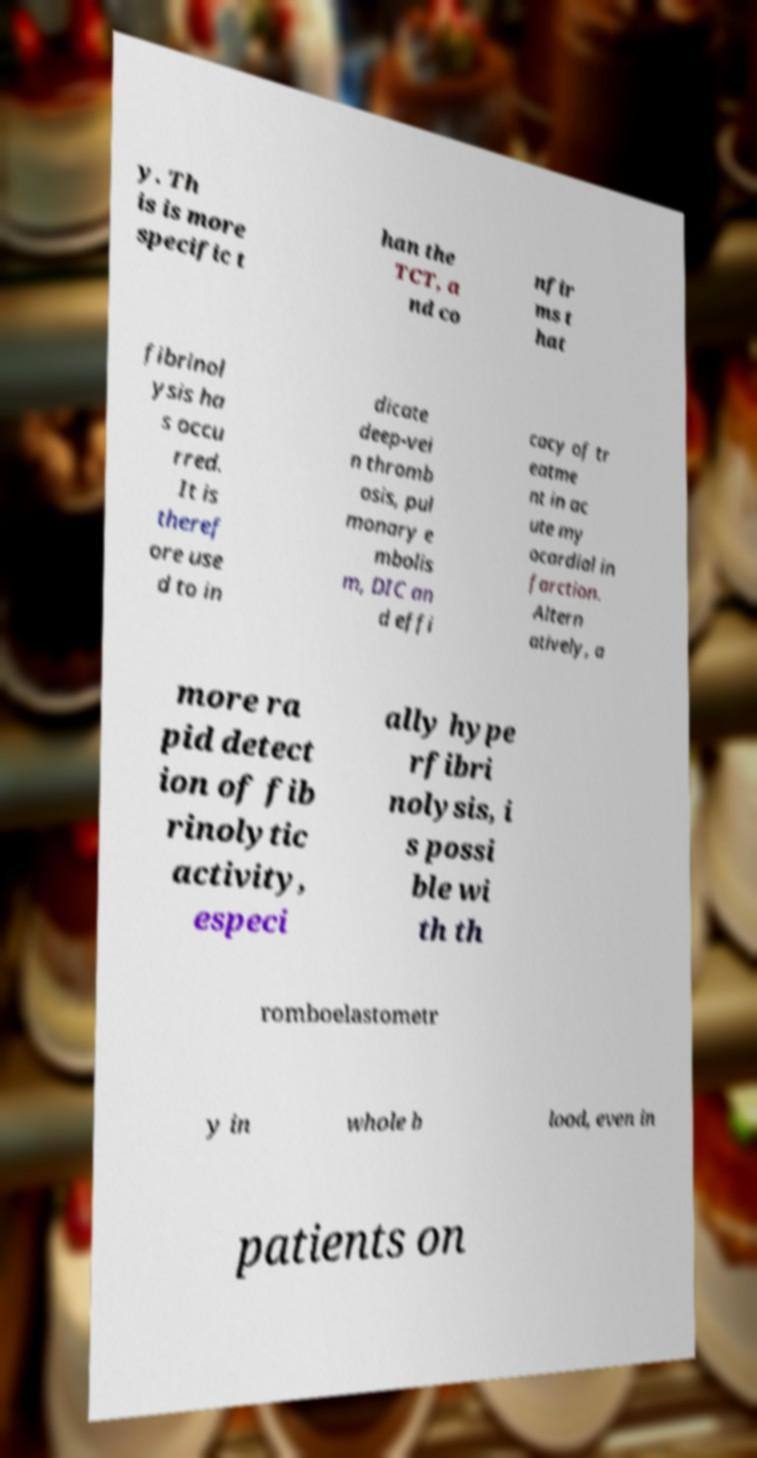Can you accurately transcribe the text from the provided image for me? y. Th is is more specific t han the TCT, a nd co nfir ms t hat fibrinol ysis ha s occu rred. It is theref ore use d to in dicate deep-vei n thromb osis, pul monary e mbolis m, DIC an d effi cacy of tr eatme nt in ac ute my ocardial in farction. Altern atively, a more ra pid detect ion of fib rinolytic activity, especi ally hype rfibri nolysis, i s possi ble wi th th romboelastometr y in whole b lood, even in patients on 